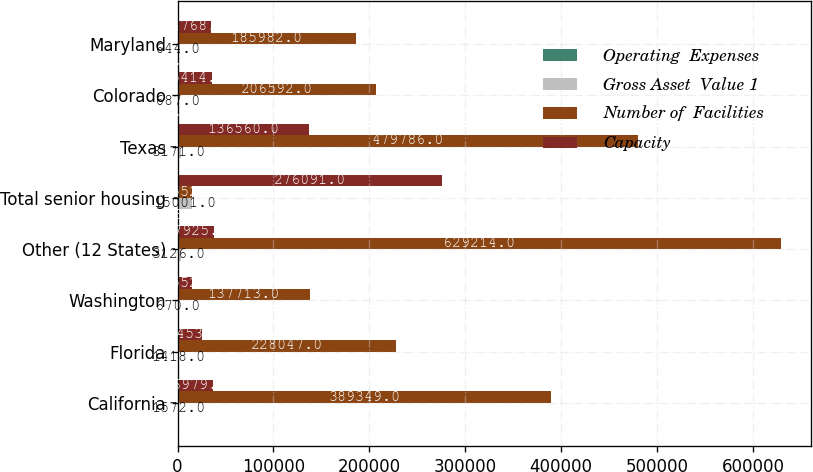<chart> <loc_0><loc_0><loc_500><loc_500><stacked_bar_chart><ecel><fcel>California<fcel>Florida<fcel>Washington<fcel>Other (12 States)<fcel>Total senior housing<fcel>Texas<fcel>Colorado<fcel>Maryland<nl><fcel>Operating  Expenses<fcel>16<fcel>11<fcel>10<fcel>27<fcel>146<fcel>19<fcel>5<fcel>7<nl><fcel>Gross Asset  Value 1<fcel>1572<fcel>1418<fcel>670<fcel>3126<fcel>15001<fcel>3171<fcel>687<fcel>644<nl><fcel>Number of  Facilities<fcel>389349<fcel>228047<fcel>137713<fcel>629214<fcel>14552<fcel>479786<fcel>206592<fcel>185982<nl><fcel>Capacity<fcel>36979<fcel>25453<fcel>14552<fcel>37925<fcel>276091<fcel>136560<fcel>35414<fcel>34768<nl></chart> 